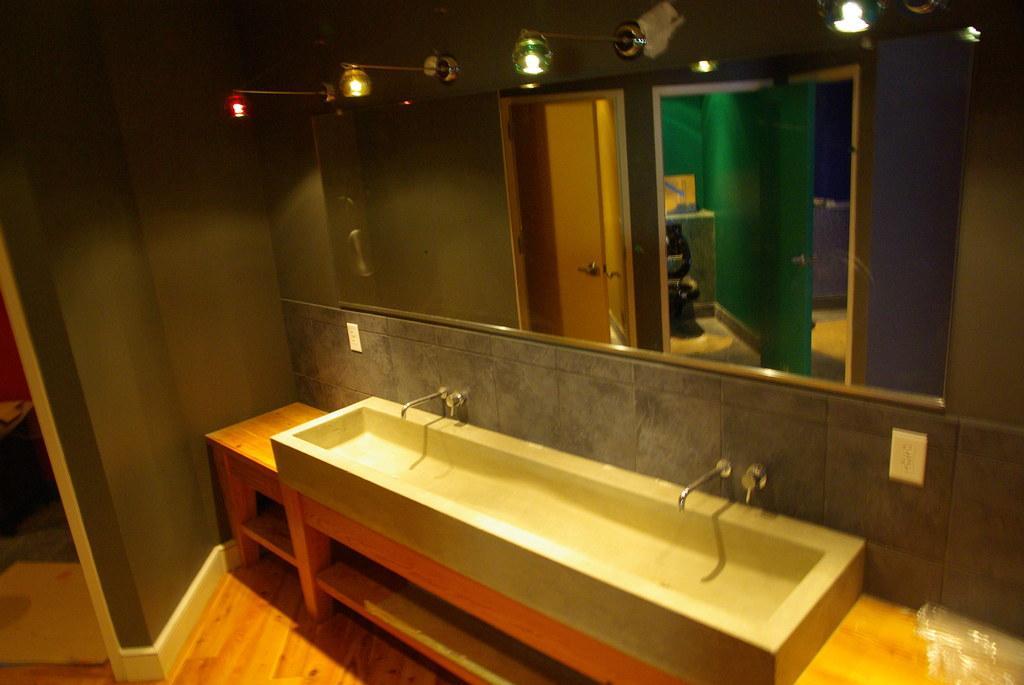In one or two sentences, can you explain what this image depicts? It is a washroom there is a wash basin and in front of the wash basin there is a big mirror and above the mirror there are colorful lights and on the left side there is a wall. 